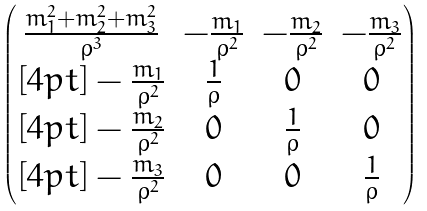Convert formula to latex. <formula><loc_0><loc_0><loc_500><loc_500>\begin{pmatrix} \frac { m _ { 1 } ^ { 2 } + m _ { 2 } ^ { 2 } + m _ { 3 } ^ { 2 } } { \rho ^ { 3 } } & - \frac { m _ { 1 } } { \rho ^ { 2 } } & - \frac { m _ { 2 } } { \rho ^ { 2 } } & - \frac { m _ { 3 } } { \rho ^ { 2 } } \\ [ 4 p t ] - \frac { m _ { 1 } } { \rho ^ { 2 } } & \frac { 1 } { \rho } & 0 & 0 \\ [ 4 p t ] - \frac { m _ { 2 } } { \rho ^ { 2 } } & 0 & \frac { 1 } { \rho } & 0 \\ [ 4 p t ] - \frac { m _ { 3 } } { \rho ^ { 2 } } & 0 & 0 & \frac { 1 } { \rho } \end{pmatrix}</formula> 